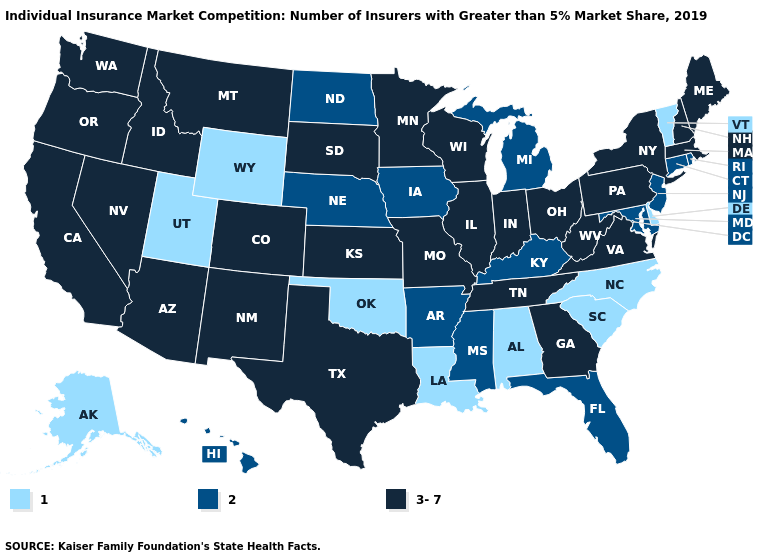Name the states that have a value in the range 2?
Concise answer only. Arkansas, Connecticut, Florida, Hawaii, Iowa, Kentucky, Maryland, Michigan, Mississippi, Nebraska, New Jersey, North Dakota, Rhode Island. Does Iowa have the highest value in the MidWest?
Keep it brief. No. Name the states that have a value in the range 3-7?
Short answer required. Arizona, California, Colorado, Georgia, Idaho, Illinois, Indiana, Kansas, Maine, Massachusetts, Minnesota, Missouri, Montana, Nevada, New Hampshire, New Mexico, New York, Ohio, Oregon, Pennsylvania, South Dakota, Tennessee, Texas, Virginia, Washington, West Virginia, Wisconsin. What is the value of New Mexico?
Be succinct. 3-7. What is the value of Texas?
Be succinct. 3-7. Name the states that have a value in the range 1?
Concise answer only. Alabama, Alaska, Delaware, Louisiana, North Carolina, Oklahoma, South Carolina, Utah, Vermont, Wyoming. What is the highest value in states that border Ohio?
Write a very short answer. 3-7. Name the states that have a value in the range 3-7?
Keep it brief. Arizona, California, Colorado, Georgia, Idaho, Illinois, Indiana, Kansas, Maine, Massachusetts, Minnesota, Missouri, Montana, Nevada, New Hampshire, New Mexico, New York, Ohio, Oregon, Pennsylvania, South Dakota, Tennessee, Texas, Virginia, Washington, West Virginia, Wisconsin. What is the value of Virginia?
Quick response, please. 3-7. Does Alaska have the highest value in the USA?
Concise answer only. No. Does Virginia have the highest value in the USA?
Write a very short answer. Yes. What is the lowest value in states that border Alabama?
Quick response, please. 2. Does Utah have the same value as Iowa?
Write a very short answer. No. What is the lowest value in states that border Wisconsin?
Write a very short answer. 2. What is the highest value in the USA?
Keep it brief. 3-7. 